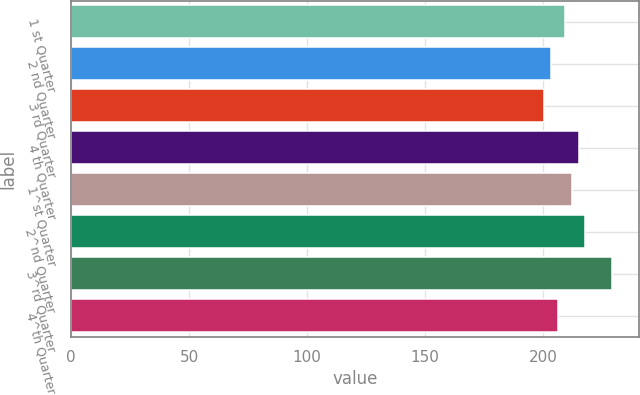<chart> <loc_0><loc_0><loc_500><loc_500><bar_chart><fcel>1 st Quarter<fcel>2 nd Quarter<fcel>3 rd Quarter<fcel>4 th Quarter<fcel>1^st Quarter<fcel>2^nd Quarter<fcel>3^rd Quarter<fcel>4^th Quarter<nl><fcel>209.18<fcel>203.12<fcel>200.23<fcel>214.96<fcel>212.07<fcel>217.85<fcel>229.1<fcel>206.29<nl></chart> 